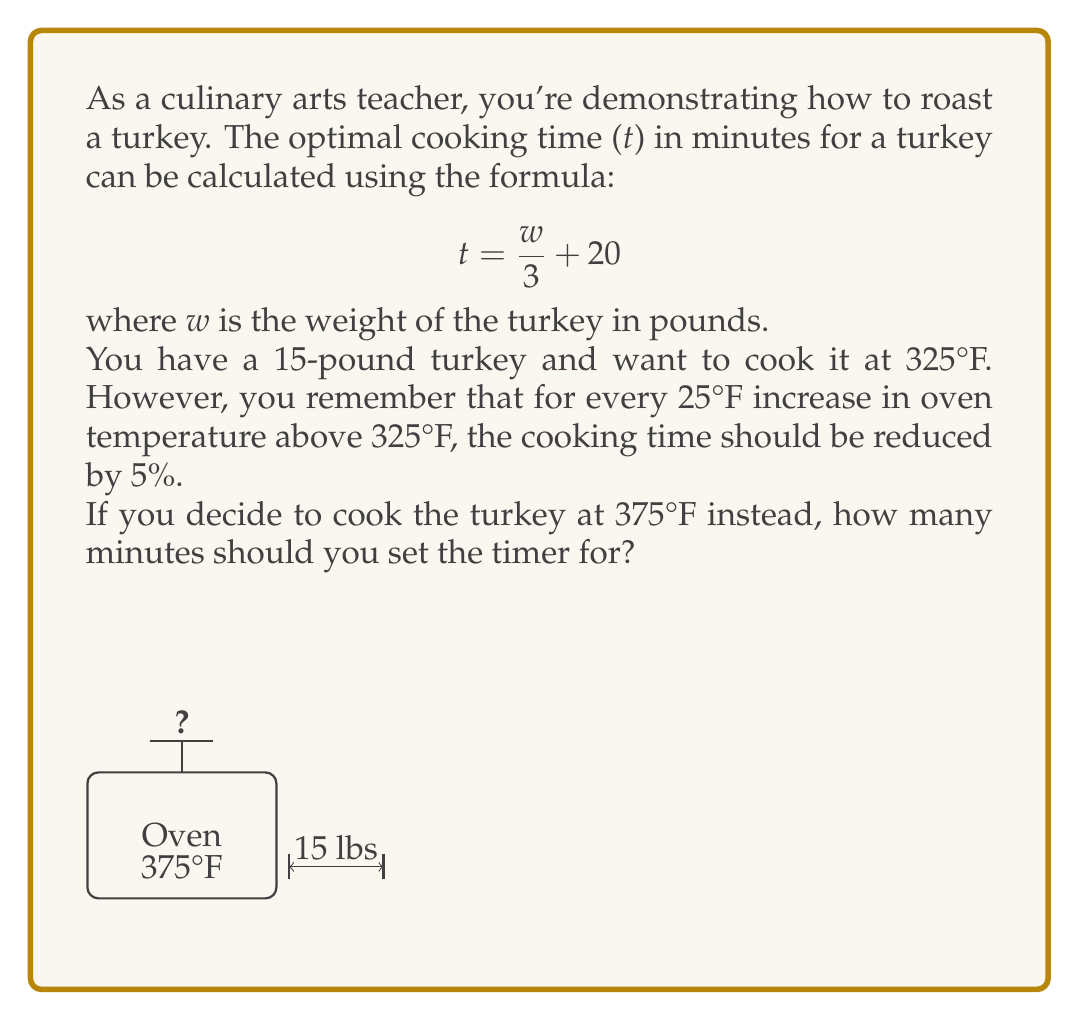Show me your answer to this math problem. Let's solve this problem step by step:

1) First, calculate the cooking time at 325°F using the given formula:
   $$ t = \frac{w}{3} + 20 $$
   $$ t = \frac{15}{3} + 20 = 5 + 20 = 25 \text{ minutes} $$

2) The temperature difference between 375°F and 325°F is:
   $$ 375°F - 325°F = 50°F $$

3) This is a 2 × 25°F increase, so we need to reduce the cooking time by 2 × 5% = 10%

4) To calculate the reduced cooking time:
   a) First, convert 10% to a decimal: 10% = 0.10
   b) Subtract this from 1 to get the percentage of time we should cook: 1 - 0.10 = 0.90
   c) Multiply the original cooking time by 0.90:
      $$ 25 \times 0.90 = 22.5 \text{ minutes} $$

5) Round to the nearest minute for practical use in the kitchen.

Therefore, you should set the timer for 23 minutes when cooking the 15-pound turkey at 375°F.
Answer: 23 minutes 